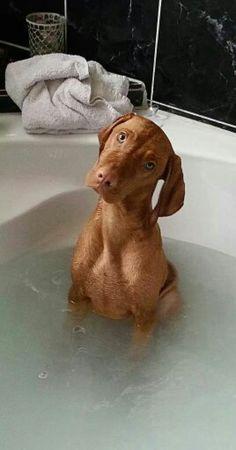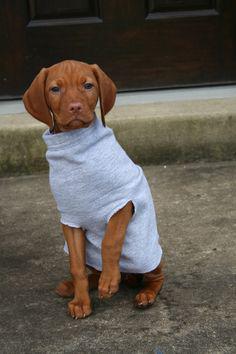The first image is the image on the left, the second image is the image on the right. For the images shown, is this caption "There are only two dogs in total." true? Answer yes or no. Yes. The first image is the image on the left, the second image is the image on the right. Evaluate the accuracy of this statement regarding the images: "The right image shows a red-orange dog reclining in a bed with the side of its head on a pillow.". Is it true? Answer yes or no. No. 